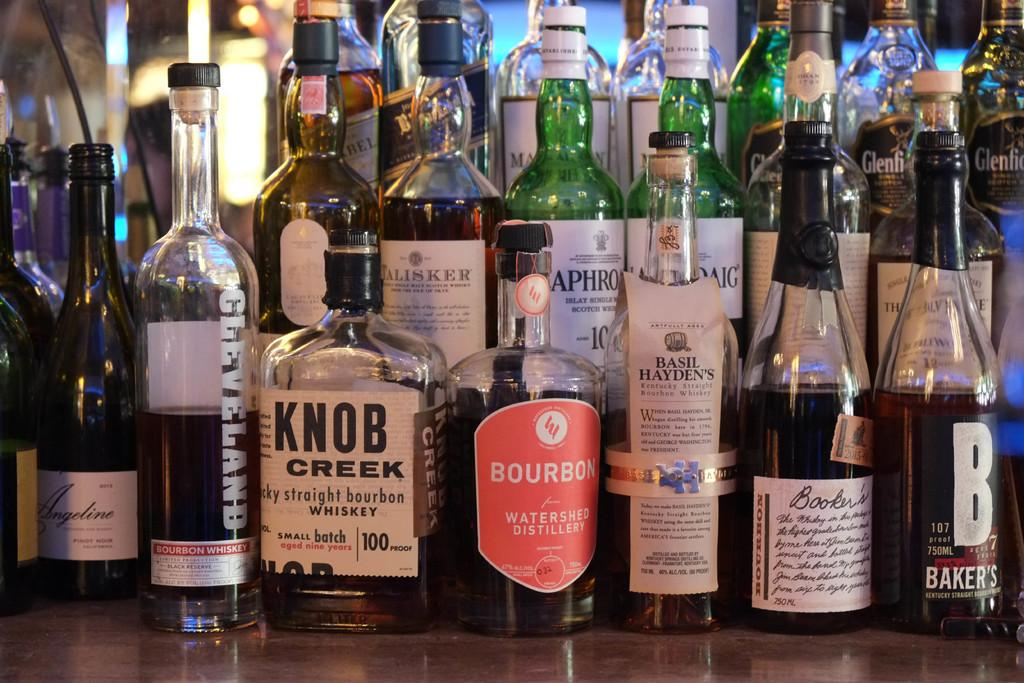<image>
Share a concise interpretation of the image provided. A bottle of Knob Creek whiskey sits with many other bottles at a bar. 